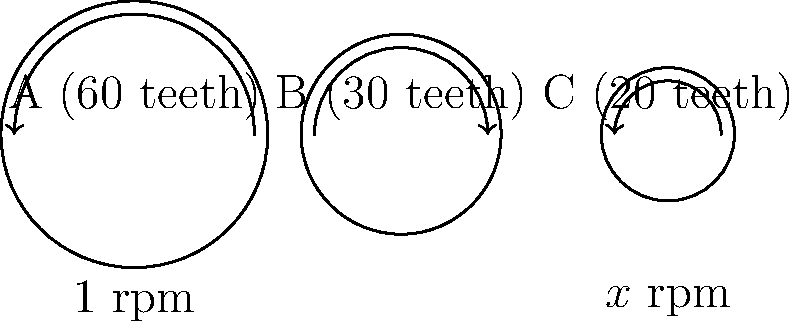In the mechanical watch movement shown above, gear A rotates at 1 rpm (revolution per minute). If gear A has 60 teeth, gear B has 30 teeth, and gear C has 20 teeth, what is the rotation speed of gear C in rpm? To solve this problem, we need to follow these steps:

1. Calculate the gear ratio between A and B:
   Ratio A:B = Teeth B : Teeth A = 30 : 60 = 1 : 2

2. Calculate the rotation speed of gear B:
   Since A rotates at 1 rpm and the ratio is 1:2, B rotates twice as fast.
   Speed of B = 1 rpm × 2 = 2 rpm

3. Calculate the gear ratio between B and C:
   Ratio B:C = Teeth C : Teeth B = 20 : 30 = 2 : 3

4. Calculate the rotation speed of gear C:
   Ratio of speeds C:B = 3:2
   Speed of C = Speed of B × (3/2) = 2 rpm × (3/2) = 3 rpm

Therefore, gear C rotates at 3 rpm.
Answer: 3 rpm 